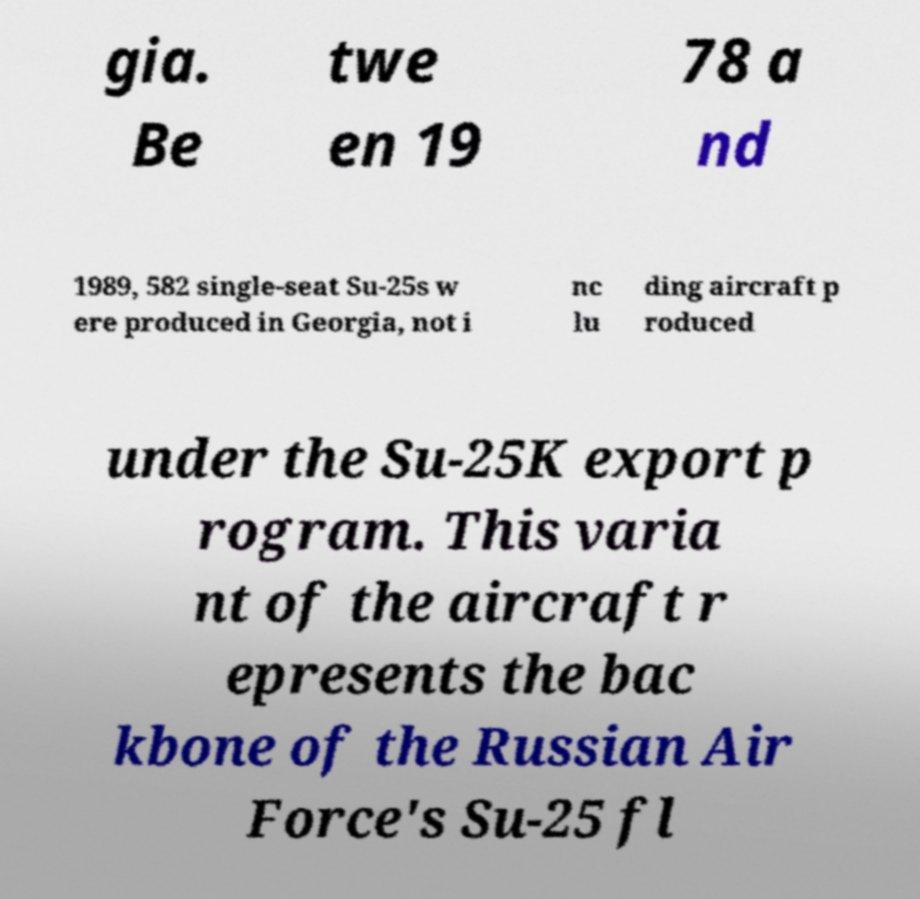Please read and relay the text visible in this image. What does it say? gia. Be twe en 19 78 a nd 1989, 582 single-seat Su-25s w ere produced in Georgia, not i nc lu ding aircraft p roduced under the Su-25K export p rogram. This varia nt of the aircraft r epresents the bac kbone of the Russian Air Force's Su-25 fl 